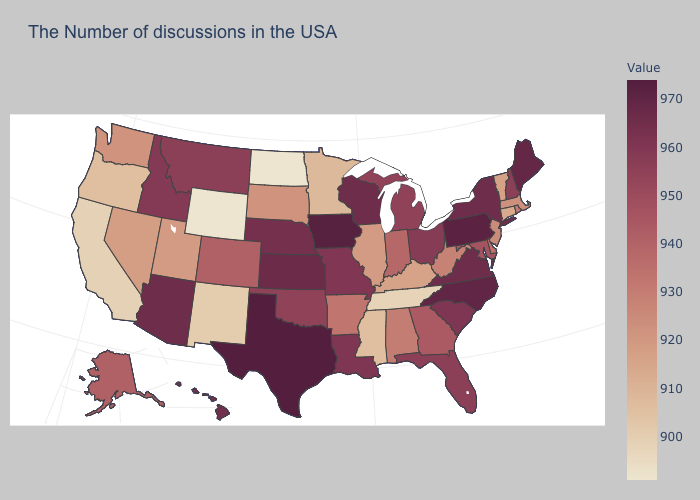Is the legend a continuous bar?
Give a very brief answer. Yes. Which states hav the highest value in the South?
Concise answer only. Texas. Among the states that border Oregon , which have the lowest value?
Answer briefly. California. Among the states that border Oklahoma , does Missouri have the lowest value?
Keep it brief. No. 